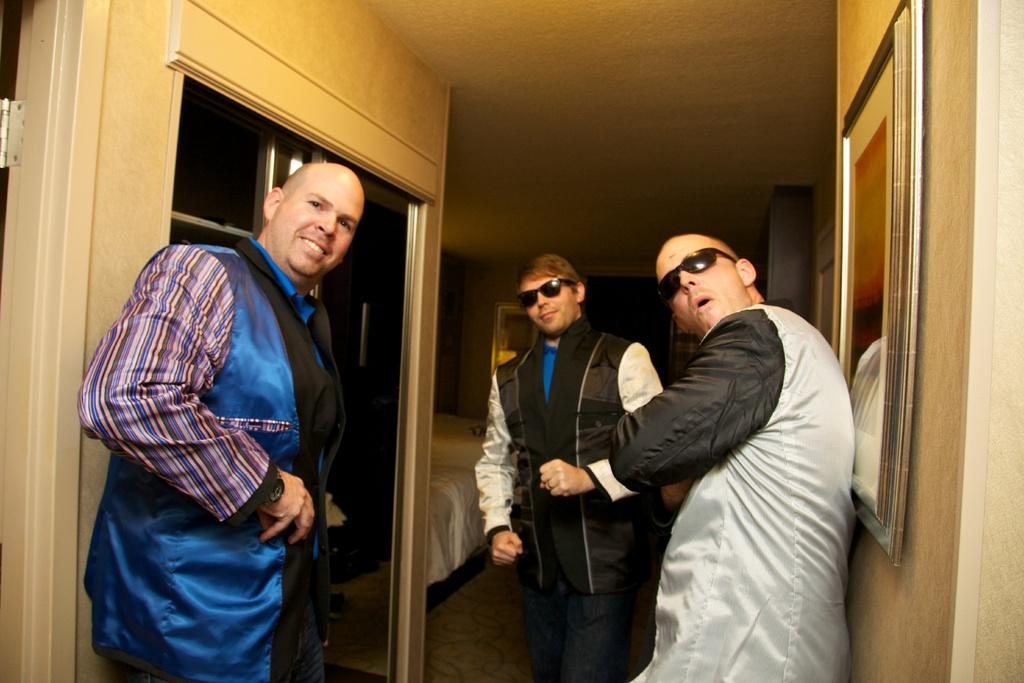What is one of the main objects in the image? There is a door in the image. How many people are visible in the image? There are three people standing in the front of the image. What piece of furniture can be seen in the image? There is a bed in the image. What object is present in the background of the image? There is a mirror in the background of the image. What type of notebook is being used by the family in the image? There is no notebook present in the image, and no family is mentioned. 